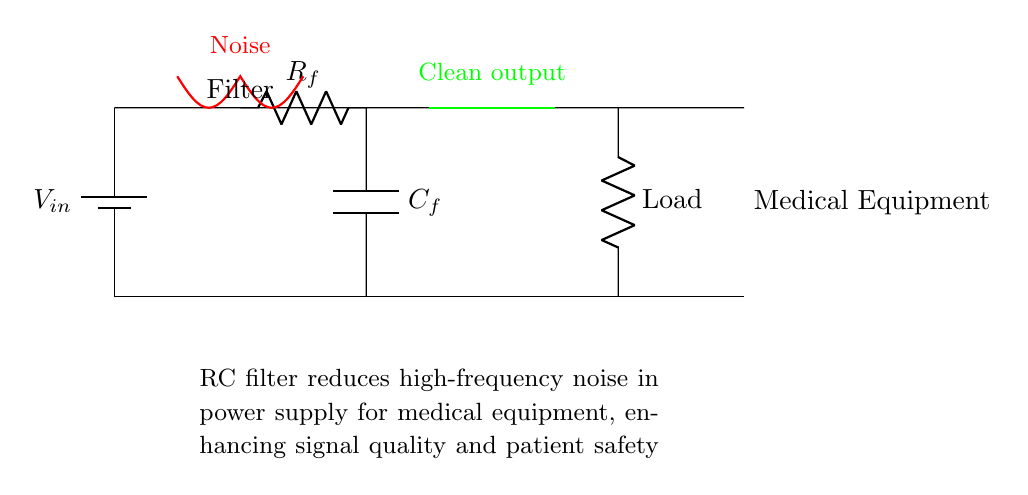What is the output after the RC filter? The clean output is indicated by the green line running horizontally at the output of the filter. This signifies that high-frequency noise has been reduced, providing a steady voltage to the load.
Answer: Clean output What components are used in the RC filter? The RC filter consists of a resistor labeled R_f and a capacitor labeled C_f. These components act together to filter out noise from the power supply.
Answer: R_f and C_f What is the role of the resistor in this circuit? The resistor R_f regulates the current flow and, along with the capacitor, determines the cutoff frequency of the filter, allowing specific frequency signals to pass while blocking others.
Answer: Current regulation What is the purpose of the capacitor in this circuit? The capacitor C_f serves to store and release electrical energy, smoothing out fluctuations in voltage and filtering out high-frequency noise from the power supply.
Answer: Smoothing voltage What type of filter is represented in this circuit diagram? This circuit uses a low-pass filter configuration because it allows low-frequency signals to pass while attenuating high-frequency noise, which is essential in medical equipment.
Answer: Low-pass filter How does this filter enhance patient safety? By reducing high-frequency noise in the power supply, the RC filter improves the quality of the signals processed by the medical equipment, which can lead to more reliable and accurate diagnoses and treatments.
Answer: Improves signal quality 